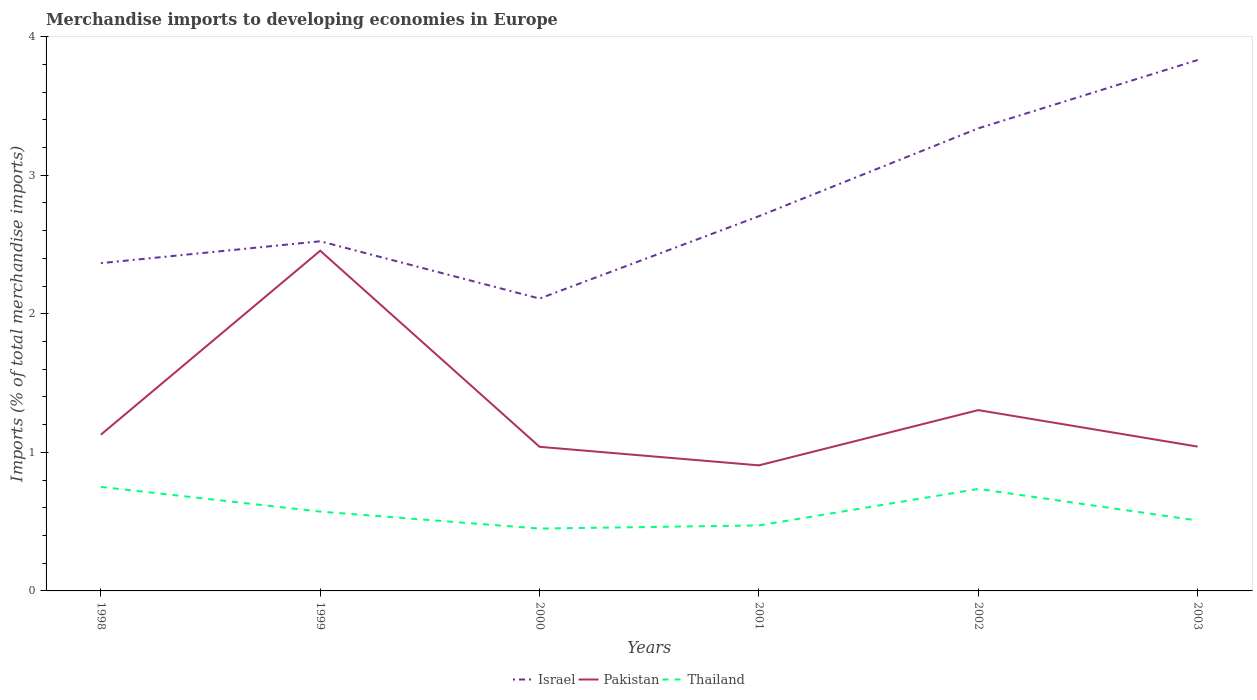Does the line corresponding to Israel intersect with the line corresponding to Thailand?
Keep it short and to the point. No. Across all years, what is the maximum percentage total merchandise imports in Israel?
Your response must be concise. 2.11. What is the total percentage total merchandise imports in Israel in the graph?
Keep it short and to the point. -1.31. What is the difference between the highest and the second highest percentage total merchandise imports in Thailand?
Your response must be concise. 0.3. How many lines are there?
Provide a succinct answer. 3. How many years are there in the graph?
Make the answer very short. 6. What is the difference between two consecutive major ticks on the Y-axis?
Provide a short and direct response. 1. Where does the legend appear in the graph?
Make the answer very short. Bottom center. How are the legend labels stacked?
Your answer should be compact. Horizontal. What is the title of the graph?
Offer a terse response. Merchandise imports to developing economies in Europe. Does "Ecuador" appear as one of the legend labels in the graph?
Offer a very short reply. No. What is the label or title of the Y-axis?
Your response must be concise. Imports (% of total merchandise imports). What is the Imports (% of total merchandise imports) of Israel in 1998?
Provide a short and direct response. 2.37. What is the Imports (% of total merchandise imports) of Pakistan in 1998?
Make the answer very short. 1.13. What is the Imports (% of total merchandise imports) of Thailand in 1998?
Offer a terse response. 0.75. What is the Imports (% of total merchandise imports) of Israel in 1999?
Your response must be concise. 2.52. What is the Imports (% of total merchandise imports) in Pakistan in 1999?
Your answer should be compact. 2.46. What is the Imports (% of total merchandise imports) in Thailand in 1999?
Give a very brief answer. 0.57. What is the Imports (% of total merchandise imports) in Israel in 2000?
Give a very brief answer. 2.11. What is the Imports (% of total merchandise imports) in Pakistan in 2000?
Make the answer very short. 1.04. What is the Imports (% of total merchandise imports) of Thailand in 2000?
Provide a short and direct response. 0.45. What is the Imports (% of total merchandise imports) of Israel in 2001?
Provide a succinct answer. 2.7. What is the Imports (% of total merchandise imports) of Pakistan in 2001?
Make the answer very short. 0.91. What is the Imports (% of total merchandise imports) in Thailand in 2001?
Offer a terse response. 0.47. What is the Imports (% of total merchandise imports) in Israel in 2002?
Provide a succinct answer. 3.34. What is the Imports (% of total merchandise imports) in Pakistan in 2002?
Offer a very short reply. 1.31. What is the Imports (% of total merchandise imports) of Thailand in 2002?
Offer a very short reply. 0.74. What is the Imports (% of total merchandise imports) in Israel in 2003?
Your answer should be compact. 3.83. What is the Imports (% of total merchandise imports) in Pakistan in 2003?
Make the answer very short. 1.04. What is the Imports (% of total merchandise imports) of Thailand in 2003?
Ensure brevity in your answer.  0.51. Across all years, what is the maximum Imports (% of total merchandise imports) of Israel?
Your answer should be very brief. 3.83. Across all years, what is the maximum Imports (% of total merchandise imports) of Pakistan?
Give a very brief answer. 2.46. Across all years, what is the maximum Imports (% of total merchandise imports) of Thailand?
Provide a succinct answer. 0.75. Across all years, what is the minimum Imports (% of total merchandise imports) of Israel?
Your answer should be very brief. 2.11. Across all years, what is the minimum Imports (% of total merchandise imports) of Pakistan?
Your response must be concise. 0.91. Across all years, what is the minimum Imports (% of total merchandise imports) of Thailand?
Ensure brevity in your answer.  0.45. What is the total Imports (% of total merchandise imports) in Israel in the graph?
Provide a short and direct response. 16.87. What is the total Imports (% of total merchandise imports) in Pakistan in the graph?
Offer a terse response. 7.88. What is the total Imports (% of total merchandise imports) of Thailand in the graph?
Your response must be concise. 3.49. What is the difference between the Imports (% of total merchandise imports) of Israel in 1998 and that in 1999?
Provide a succinct answer. -0.16. What is the difference between the Imports (% of total merchandise imports) of Pakistan in 1998 and that in 1999?
Ensure brevity in your answer.  -1.33. What is the difference between the Imports (% of total merchandise imports) of Thailand in 1998 and that in 1999?
Make the answer very short. 0.18. What is the difference between the Imports (% of total merchandise imports) of Israel in 1998 and that in 2000?
Give a very brief answer. 0.26. What is the difference between the Imports (% of total merchandise imports) in Pakistan in 1998 and that in 2000?
Your answer should be compact. 0.09. What is the difference between the Imports (% of total merchandise imports) of Thailand in 1998 and that in 2000?
Offer a terse response. 0.3. What is the difference between the Imports (% of total merchandise imports) of Israel in 1998 and that in 2001?
Give a very brief answer. -0.34. What is the difference between the Imports (% of total merchandise imports) of Pakistan in 1998 and that in 2001?
Ensure brevity in your answer.  0.22. What is the difference between the Imports (% of total merchandise imports) of Thailand in 1998 and that in 2001?
Your answer should be compact. 0.28. What is the difference between the Imports (% of total merchandise imports) of Israel in 1998 and that in 2002?
Ensure brevity in your answer.  -0.97. What is the difference between the Imports (% of total merchandise imports) of Pakistan in 1998 and that in 2002?
Offer a very short reply. -0.18. What is the difference between the Imports (% of total merchandise imports) of Thailand in 1998 and that in 2002?
Ensure brevity in your answer.  0.01. What is the difference between the Imports (% of total merchandise imports) in Israel in 1998 and that in 2003?
Your answer should be compact. -1.47. What is the difference between the Imports (% of total merchandise imports) of Pakistan in 1998 and that in 2003?
Ensure brevity in your answer.  0.09. What is the difference between the Imports (% of total merchandise imports) of Thailand in 1998 and that in 2003?
Ensure brevity in your answer.  0.24. What is the difference between the Imports (% of total merchandise imports) in Israel in 1999 and that in 2000?
Offer a very short reply. 0.41. What is the difference between the Imports (% of total merchandise imports) of Pakistan in 1999 and that in 2000?
Your response must be concise. 1.42. What is the difference between the Imports (% of total merchandise imports) in Thailand in 1999 and that in 2000?
Offer a terse response. 0.12. What is the difference between the Imports (% of total merchandise imports) in Israel in 1999 and that in 2001?
Offer a very short reply. -0.18. What is the difference between the Imports (% of total merchandise imports) of Pakistan in 1999 and that in 2001?
Your answer should be very brief. 1.55. What is the difference between the Imports (% of total merchandise imports) of Thailand in 1999 and that in 2001?
Provide a short and direct response. 0.1. What is the difference between the Imports (% of total merchandise imports) of Israel in 1999 and that in 2002?
Offer a terse response. -0.82. What is the difference between the Imports (% of total merchandise imports) of Pakistan in 1999 and that in 2002?
Your answer should be compact. 1.15. What is the difference between the Imports (% of total merchandise imports) in Thailand in 1999 and that in 2002?
Your answer should be very brief. -0.16. What is the difference between the Imports (% of total merchandise imports) in Israel in 1999 and that in 2003?
Keep it short and to the point. -1.31. What is the difference between the Imports (% of total merchandise imports) in Pakistan in 1999 and that in 2003?
Provide a succinct answer. 1.41. What is the difference between the Imports (% of total merchandise imports) of Thailand in 1999 and that in 2003?
Offer a terse response. 0.06. What is the difference between the Imports (% of total merchandise imports) of Israel in 2000 and that in 2001?
Your response must be concise. -0.59. What is the difference between the Imports (% of total merchandise imports) of Pakistan in 2000 and that in 2001?
Make the answer very short. 0.13. What is the difference between the Imports (% of total merchandise imports) in Thailand in 2000 and that in 2001?
Offer a terse response. -0.02. What is the difference between the Imports (% of total merchandise imports) in Israel in 2000 and that in 2002?
Offer a very short reply. -1.23. What is the difference between the Imports (% of total merchandise imports) in Pakistan in 2000 and that in 2002?
Provide a short and direct response. -0.27. What is the difference between the Imports (% of total merchandise imports) in Thailand in 2000 and that in 2002?
Provide a short and direct response. -0.29. What is the difference between the Imports (% of total merchandise imports) in Israel in 2000 and that in 2003?
Offer a very short reply. -1.72. What is the difference between the Imports (% of total merchandise imports) in Pakistan in 2000 and that in 2003?
Ensure brevity in your answer.  -0. What is the difference between the Imports (% of total merchandise imports) of Thailand in 2000 and that in 2003?
Offer a terse response. -0.06. What is the difference between the Imports (% of total merchandise imports) of Israel in 2001 and that in 2002?
Provide a short and direct response. -0.63. What is the difference between the Imports (% of total merchandise imports) in Pakistan in 2001 and that in 2002?
Offer a terse response. -0.4. What is the difference between the Imports (% of total merchandise imports) of Thailand in 2001 and that in 2002?
Your answer should be very brief. -0.26. What is the difference between the Imports (% of total merchandise imports) of Israel in 2001 and that in 2003?
Your answer should be very brief. -1.13. What is the difference between the Imports (% of total merchandise imports) in Pakistan in 2001 and that in 2003?
Offer a very short reply. -0.14. What is the difference between the Imports (% of total merchandise imports) of Thailand in 2001 and that in 2003?
Give a very brief answer. -0.04. What is the difference between the Imports (% of total merchandise imports) of Israel in 2002 and that in 2003?
Provide a succinct answer. -0.49. What is the difference between the Imports (% of total merchandise imports) in Pakistan in 2002 and that in 2003?
Your response must be concise. 0.26. What is the difference between the Imports (% of total merchandise imports) in Thailand in 2002 and that in 2003?
Give a very brief answer. 0.23. What is the difference between the Imports (% of total merchandise imports) of Israel in 1998 and the Imports (% of total merchandise imports) of Pakistan in 1999?
Provide a short and direct response. -0.09. What is the difference between the Imports (% of total merchandise imports) of Israel in 1998 and the Imports (% of total merchandise imports) of Thailand in 1999?
Provide a short and direct response. 1.79. What is the difference between the Imports (% of total merchandise imports) in Pakistan in 1998 and the Imports (% of total merchandise imports) in Thailand in 1999?
Make the answer very short. 0.56. What is the difference between the Imports (% of total merchandise imports) of Israel in 1998 and the Imports (% of total merchandise imports) of Pakistan in 2000?
Your response must be concise. 1.33. What is the difference between the Imports (% of total merchandise imports) in Israel in 1998 and the Imports (% of total merchandise imports) in Thailand in 2000?
Give a very brief answer. 1.92. What is the difference between the Imports (% of total merchandise imports) in Pakistan in 1998 and the Imports (% of total merchandise imports) in Thailand in 2000?
Offer a very short reply. 0.68. What is the difference between the Imports (% of total merchandise imports) in Israel in 1998 and the Imports (% of total merchandise imports) in Pakistan in 2001?
Your answer should be very brief. 1.46. What is the difference between the Imports (% of total merchandise imports) in Israel in 1998 and the Imports (% of total merchandise imports) in Thailand in 2001?
Your answer should be compact. 1.89. What is the difference between the Imports (% of total merchandise imports) of Pakistan in 1998 and the Imports (% of total merchandise imports) of Thailand in 2001?
Provide a succinct answer. 0.65. What is the difference between the Imports (% of total merchandise imports) in Israel in 1998 and the Imports (% of total merchandise imports) in Pakistan in 2002?
Your answer should be very brief. 1.06. What is the difference between the Imports (% of total merchandise imports) in Israel in 1998 and the Imports (% of total merchandise imports) in Thailand in 2002?
Provide a succinct answer. 1.63. What is the difference between the Imports (% of total merchandise imports) of Pakistan in 1998 and the Imports (% of total merchandise imports) of Thailand in 2002?
Your answer should be compact. 0.39. What is the difference between the Imports (% of total merchandise imports) in Israel in 1998 and the Imports (% of total merchandise imports) in Pakistan in 2003?
Give a very brief answer. 1.32. What is the difference between the Imports (% of total merchandise imports) of Israel in 1998 and the Imports (% of total merchandise imports) of Thailand in 2003?
Keep it short and to the point. 1.86. What is the difference between the Imports (% of total merchandise imports) of Pakistan in 1998 and the Imports (% of total merchandise imports) of Thailand in 2003?
Provide a short and direct response. 0.62. What is the difference between the Imports (% of total merchandise imports) of Israel in 1999 and the Imports (% of total merchandise imports) of Pakistan in 2000?
Offer a terse response. 1.48. What is the difference between the Imports (% of total merchandise imports) in Israel in 1999 and the Imports (% of total merchandise imports) in Thailand in 2000?
Your response must be concise. 2.07. What is the difference between the Imports (% of total merchandise imports) in Pakistan in 1999 and the Imports (% of total merchandise imports) in Thailand in 2000?
Ensure brevity in your answer.  2.01. What is the difference between the Imports (% of total merchandise imports) of Israel in 1999 and the Imports (% of total merchandise imports) of Pakistan in 2001?
Your response must be concise. 1.62. What is the difference between the Imports (% of total merchandise imports) in Israel in 1999 and the Imports (% of total merchandise imports) in Thailand in 2001?
Your answer should be very brief. 2.05. What is the difference between the Imports (% of total merchandise imports) in Pakistan in 1999 and the Imports (% of total merchandise imports) in Thailand in 2001?
Keep it short and to the point. 1.98. What is the difference between the Imports (% of total merchandise imports) in Israel in 1999 and the Imports (% of total merchandise imports) in Pakistan in 2002?
Your answer should be compact. 1.22. What is the difference between the Imports (% of total merchandise imports) in Israel in 1999 and the Imports (% of total merchandise imports) in Thailand in 2002?
Make the answer very short. 1.79. What is the difference between the Imports (% of total merchandise imports) of Pakistan in 1999 and the Imports (% of total merchandise imports) of Thailand in 2002?
Offer a terse response. 1.72. What is the difference between the Imports (% of total merchandise imports) of Israel in 1999 and the Imports (% of total merchandise imports) of Pakistan in 2003?
Provide a succinct answer. 1.48. What is the difference between the Imports (% of total merchandise imports) in Israel in 1999 and the Imports (% of total merchandise imports) in Thailand in 2003?
Your answer should be compact. 2.02. What is the difference between the Imports (% of total merchandise imports) of Pakistan in 1999 and the Imports (% of total merchandise imports) of Thailand in 2003?
Make the answer very short. 1.95. What is the difference between the Imports (% of total merchandise imports) in Israel in 2000 and the Imports (% of total merchandise imports) in Pakistan in 2001?
Your answer should be very brief. 1.2. What is the difference between the Imports (% of total merchandise imports) in Israel in 2000 and the Imports (% of total merchandise imports) in Thailand in 2001?
Keep it short and to the point. 1.64. What is the difference between the Imports (% of total merchandise imports) of Pakistan in 2000 and the Imports (% of total merchandise imports) of Thailand in 2001?
Your answer should be very brief. 0.57. What is the difference between the Imports (% of total merchandise imports) in Israel in 2000 and the Imports (% of total merchandise imports) in Pakistan in 2002?
Ensure brevity in your answer.  0.8. What is the difference between the Imports (% of total merchandise imports) in Israel in 2000 and the Imports (% of total merchandise imports) in Thailand in 2002?
Give a very brief answer. 1.37. What is the difference between the Imports (% of total merchandise imports) of Pakistan in 2000 and the Imports (% of total merchandise imports) of Thailand in 2002?
Provide a short and direct response. 0.3. What is the difference between the Imports (% of total merchandise imports) of Israel in 2000 and the Imports (% of total merchandise imports) of Pakistan in 2003?
Offer a terse response. 1.07. What is the difference between the Imports (% of total merchandise imports) in Israel in 2000 and the Imports (% of total merchandise imports) in Thailand in 2003?
Provide a succinct answer. 1.6. What is the difference between the Imports (% of total merchandise imports) of Pakistan in 2000 and the Imports (% of total merchandise imports) of Thailand in 2003?
Offer a very short reply. 0.53. What is the difference between the Imports (% of total merchandise imports) in Israel in 2001 and the Imports (% of total merchandise imports) in Pakistan in 2002?
Provide a succinct answer. 1.4. What is the difference between the Imports (% of total merchandise imports) of Israel in 2001 and the Imports (% of total merchandise imports) of Thailand in 2002?
Provide a short and direct response. 1.97. What is the difference between the Imports (% of total merchandise imports) of Pakistan in 2001 and the Imports (% of total merchandise imports) of Thailand in 2002?
Your answer should be very brief. 0.17. What is the difference between the Imports (% of total merchandise imports) in Israel in 2001 and the Imports (% of total merchandise imports) in Pakistan in 2003?
Offer a very short reply. 1.66. What is the difference between the Imports (% of total merchandise imports) of Israel in 2001 and the Imports (% of total merchandise imports) of Thailand in 2003?
Your answer should be very brief. 2.2. What is the difference between the Imports (% of total merchandise imports) of Pakistan in 2001 and the Imports (% of total merchandise imports) of Thailand in 2003?
Make the answer very short. 0.4. What is the difference between the Imports (% of total merchandise imports) of Israel in 2002 and the Imports (% of total merchandise imports) of Pakistan in 2003?
Your response must be concise. 2.3. What is the difference between the Imports (% of total merchandise imports) in Israel in 2002 and the Imports (% of total merchandise imports) in Thailand in 2003?
Provide a succinct answer. 2.83. What is the difference between the Imports (% of total merchandise imports) of Pakistan in 2002 and the Imports (% of total merchandise imports) of Thailand in 2003?
Give a very brief answer. 0.8. What is the average Imports (% of total merchandise imports) of Israel per year?
Give a very brief answer. 2.81. What is the average Imports (% of total merchandise imports) in Pakistan per year?
Keep it short and to the point. 1.31. What is the average Imports (% of total merchandise imports) in Thailand per year?
Your response must be concise. 0.58. In the year 1998, what is the difference between the Imports (% of total merchandise imports) of Israel and Imports (% of total merchandise imports) of Pakistan?
Give a very brief answer. 1.24. In the year 1998, what is the difference between the Imports (% of total merchandise imports) of Israel and Imports (% of total merchandise imports) of Thailand?
Your response must be concise. 1.61. In the year 1998, what is the difference between the Imports (% of total merchandise imports) of Pakistan and Imports (% of total merchandise imports) of Thailand?
Your response must be concise. 0.38. In the year 1999, what is the difference between the Imports (% of total merchandise imports) of Israel and Imports (% of total merchandise imports) of Pakistan?
Provide a short and direct response. 0.07. In the year 1999, what is the difference between the Imports (% of total merchandise imports) of Israel and Imports (% of total merchandise imports) of Thailand?
Your response must be concise. 1.95. In the year 1999, what is the difference between the Imports (% of total merchandise imports) of Pakistan and Imports (% of total merchandise imports) of Thailand?
Provide a short and direct response. 1.88. In the year 2000, what is the difference between the Imports (% of total merchandise imports) in Israel and Imports (% of total merchandise imports) in Pakistan?
Keep it short and to the point. 1.07. In the year 2000, what is the difference between the Imports (% of total merchandise imports) in Israel and Imports (% of total merchandise imports) in Thailand?
Your response must be concise. 1.66. In the year 2000, what is the difference between the Imports (% of total merchandise imports) of Pakistan and Imports (% of total merchandise imports) of Thailand?
Your response must be concise. 0.59. In the year 2001, what is the difference between the Imports (% of total merchandise imports) in Israel and Imports (% of total merchandise imports) in Pakistan?
Your answer should be very brief. 1.8. In the year 2001, what is the difference between the Imports (% of total merchandise imports) of Israel and Imports (% of total merchandise imports) of Thailand?
Offer a very short reply. 2.23. In the year 2001, what is the difference between the Imports (% of total merchandise imports) of Pakistan and Imports (% of total merchandise imports) of Thailand?
Provide a succinct answer. 0.43. In the year 2002, what is the difference between the Imports (% of total merchandise imports) in Israel and Imports (% of total merchandise imports) in Pakistan?
Your answer should be compact. 2.03. In the year 2002, what is the difference between the Imports (% of total merchandise imports) in Israel and Imports (% of total merchandise imports) in Thailand?
Offer a very short reply. 2.6. In the year 2002, what is the difference between the Imports (% of total merchandise imports) in Pakistan and Imports (% of total merchandise imports) in Thailand?
Offer a terse response. 0.57. In the year 2003, what is the difference between the Imports (% of total merchandise imports) in Israel and Imports (% of total merchandise imports) in Pakistan?
Keep it short and to the point. 2.79. In the year 2003, what is the difference between the Imports (% of total merchandise imports) of Israel and Imports (% of total merchandise imports) of Thailand?
Provide a succinct answer. 3.32. In the year 2003, what is the difference between the Imports (% of total merchandise imports) of Pakistan and Imports (% of total merchandise imports) of Thailand?
Offer a very short reply. 0.53. What is the ratio of the Imports (% of total merchandise imports) in Israel in 1998 to that in 1999?
Keep it short and to the point. 0.94. What is the ratio of the Imports (% of total merchandise imports) of Pakistan in 1998 to that in 1999?
Give a very brief answer. 0.46. What is the ratio of the Imports (% of total merchandise imports) of Thailand in 1998 to that in 1999?
Your answer should be very brief. 1.31. What is the ratio of the Imports (% of total merchandise imports) of Israel in 1998 to that in 2000?
Ensure brevity in your answer.  1.12. What is the ratio of the Imports (% of total merchandise imports) of Pakistan in 1998 to that in 2000?
Offer a terse response. 1.08. What is the ratio of the Imports (% of total merchandise imports) of Thailand in 1998 to that in 2000?
Make the answer very short. 1.67. What is the ratio of the Imports (% of total merchandise imports) of Israel in 1998 to that in 2001?
Your answer should be compact. 0.87. What is the ratio of the Imports (% of total merchandise imports) of Pakistan in 1998 to that in 2001?
Provide a short and direct response. 1.24. What is the ratio of the Imports (% of total merchandise imports) in Thailand in 1998 to that in 2001?
Keep it short and to the point. 1.59. What is the ratio of the Imports (% of total merchandise imports) in Israel in 1998 to that in 2002?
Make the answer very short. 0.71. What is the ratio of the Imports (% of total merchandise imports) in Pakistan in 1998 to that in 2002?
Ensure brevity in your answer.  0.86. What is the ratio of the Imports (% of total merchandise imports) of Thailand in 1998 to that in 2002?
Provide a succinct answer. 1.02. What is the ratio of the Imports (% of total merchandise imports) in Israel in 1998 to that in 2003?
Make the answer very short. 0.62. What is the ratio of the Imports (% of total merchandise imports) in Pakistan in 1998 to that in 2003?
Give a very brief answer. 1.08. What is the ratio of the Imports (% of total merchandise imports) of Thailand in 1998 to that in 2003?
Offer a very short reply. 1.48. What is the ratio of the Imports (% of total merchandise imports) of Israel in 1999 to that in 2000?
Your answer should be compact. 1.2. What is the ratio of the Imports (% of total merchandise imports) of Pakistan in 1999 to that in 2000?
Your answer should be very brief. 2.36. What is the ratio of the Imports (% of total merchandise imports) of Thailand in 1999 to that in 2000?
Offer a very short reply. 1.27. What is the ratio of the Imports (% of total merchandise imports) of Israel in 1999 to that in 2001?
Your answer should be very brief. 0.93. What is the ratio of the Imports (% of total merchandise imports) in Pakistan in 1999 to that in 2001?
Make the answer very short. 2.71. What is the ratio of the Imports (% of total merchandise imports) in Thailand in 1999 to that in 2001?
Provide a succinct answer. 1.21. What is the ratio of the Imports (% of total merchandise imports) of Israel in 1999 to that in 2002?
Your response must be concise. 0.76. What is the ratio of the Imports (% of total merchandise imports) in Pakistan in 1999 to that in 2002?
Your answer should be compact. 1.88. What is the ratio of the Imports (% of total merchandise imports) of Thailand in 1999 to that in 2002?
Your response must be concise. 0.78. What is the ratio of the Imports (% of total merchandise imports) of Israel in 1999 to that in 2003?
Make the answer very short. 0.66. What is the ratio of the Imports (% of total merchandise imports) in Pakistan in 1999 to that in 2003?
Keep it short and to the point. 2.36. What is the ratio of the Imports (% of total merchandise imports) in Thailand in 1999 to that in 2003?
Offer a terse response. 1.13. What is the ratio of the Imports (% of total merchandise imports) in Israel in 2000 to that in 2001?
Keep it short and to the point. 0.78. What is the ratio of the Imports (% of total merchandise imports) of Pakistan in 2000 to that in 2001?
Your answer should be compact. 1.15. What is the ratio of the Imports (% of total merchandise imports) in Thailand in 2000 to that in 2001?
Offer a terse response. 0.95. What is the ratio of the Imports (% of total merchandise imports) in Israel in 2000 to that in 2002?
Offer a very short reply. 0.63. What is the ratio of the Imports (% of total merchandise imports) in Pakistan in 2000 to that in 2002?
Provide a succinct answer. 0.8. What is the ratio of the Imports (% of total merchandise imports) of Thailand in 2000 to that in 2002?
Your answer should be very brief. 0.61. What is the ratio of the Imports (% of total merchandise imports) in Israel in 2000 to that in 2003?
Ensure brevity in your answer.  0.55. What is the ratio of the Imports (% of total merchandise imports) of Pakistan in 2000 to that in 2003?
Offer a very short reply. 1. What is the ratio of the Imports (% of total merchandise imports) in Thailand in 2000 to that in 2003?
Offer a very short reply. 0.89. What is the ratio of the Imports (% of total merchandise imports) in Israel in 2001 to that in 2002?
Provide a short and direct response. 0.81. What is the ratio of the Imports (% of total merchandise imports) of Pakistan in 2001 to that in 2002?
Give a very brief answer. 0.69. What is the ratio of the Imports (% of total merchandise imports) of Thailand in 2001 to that in 2002?
Your response must be concise. 0.64. What is the ratio of the Imports (% of total merchandise imports) in Israel in 2001 to that in 2003?
Keep it short and to the point. 0.71. What is the ratio of the Imports (% of total merchandise imports) in Pakistan in 2001 to that in 2003?
Make the answer very short. 0.87. What is the ratio of the Imports (% of total merchandise imports) in Thailand in 2001 to that in 2003?
Offer a terse response. 0.93. What is the ratio of the Imports (% of total merchandise imports) in Israel in 2002 to that in 2003?
Ensure brevity in your answer.  0.87. What is the ratio of the Imports (% of total merchandise imports) of Pakistan in 2002 to that in 2003?
Your response must be concise. 1.25. What is the ratio of the Imports (% of total merchandise imports) in Thailand in 2002 to that in 2003?
Offer a terse response. 1.45. What is the difference between the highest and the second highest Imports (% of total merchandise imports) of Israel?
Give a very brief answer. 0.49. What is the difference between the highest and the second highest Imports (% of total merchandise imports) of Pakistan?
Provide a short and direct response. 1.15. What is the difference between the highest and the second highest Imports (% of total merchandise imports) in Thailand?
Provide a succinct answer. 0.01. What is the difference between the highest and the lowest Imports (% of total merchandise imports) in Israel?
Provide a short and direct response. 1.72. What is the difference between the highest and the lowest Imports (% of total merchandise imports) in Pakistan?
Offer a terse response. 1.55. What is the difference between the highest and the lowest Imports (% of total merchandise imports) in Thailand?
Your answer should be very brief. 0.3. 